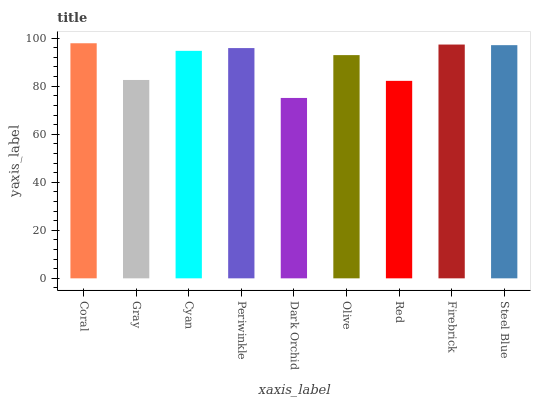Is Gray the minimum?
Answer yes or no. No. Is Gray the maximum?
Answer yes or no. No. Is Coral greater than Gray?
Answer yes or no. Yes. Is Gray less than Coral?
Answer yes or no. Yes. Is Gray greater than Coral?
Answer yes or no. No. Is Coral less than Gray?
Answer yes or no. No. Is Cyan the high median?
Answer yes or no. Yes. Is Cyan the low median?
Answer yes or no. Yes. Is Gray the high median?
Answer yes or no. No. Is Periwinkle the low median?
Answer yes or no. No. 